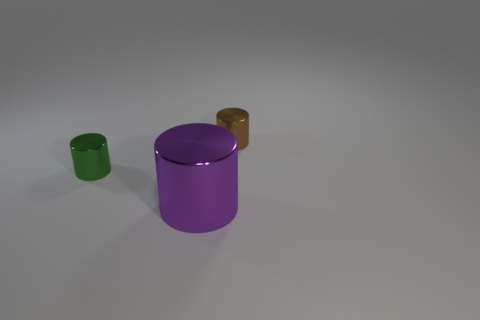What could be the function of these cylinders in real life? These cylinders could represent various types of containers or storage items in real life, such as canisters for tea, coffee, or other dry goods. The reflective surface suggests they might be decorative or used in a setting where aesthetics are considered, like a modern kitchen or office. 